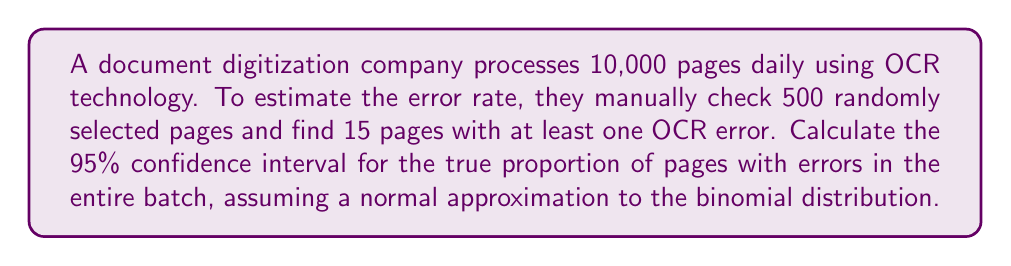Provide a solution to this math problem. To calculate the confidence interval, we'll follow these steps:

1. Calculate the sample proportion:
   $\hat{p} = \frac{\text{number of pages with errors}}{\text{sample size}} = \frac{15}{500} = 0.03$

2. Calculate the standard error:
   $SE = \sqrt{\frac{\hat{p}(1-\hat{p})}{n}} = \sqrt{\frac{0.03(1-0.03)}{500}} = \sqrt{\frac{0.0291}{500}} = 0.00762$

3. For a 95% confidence interval, use $z = 1.96$ (from the standard normal distribution)

4. Calculate the margin of error:
   $E = z \cdot SE = 1.96 \cdot 0.00762 = 0.01494$

5. Compute the confidence interval:
   Lower bound: $\hat{p} - E = 0.03 - 0.01494 = 0.01506$
   Upper bound: $\hat{p} + E = 0.03 + 0.01494 = 0.04494$

Therefore, the 95% confidence interval is (0.01506, 0.04494) or approximately (1.51%, 4.49%).
Answer: (1.51%, 4.49%) 